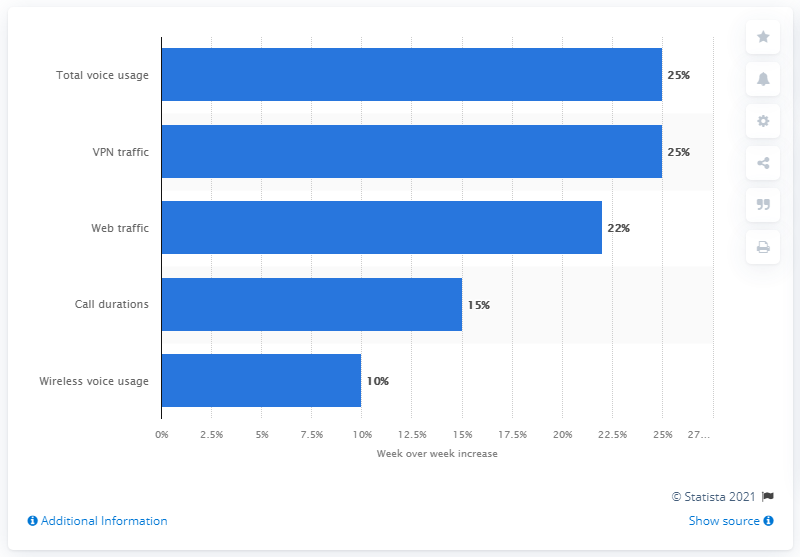Point out several critical features in this image. The volume of VPN traffic increased significantly during the COVID-19 pandemic by 25%. 